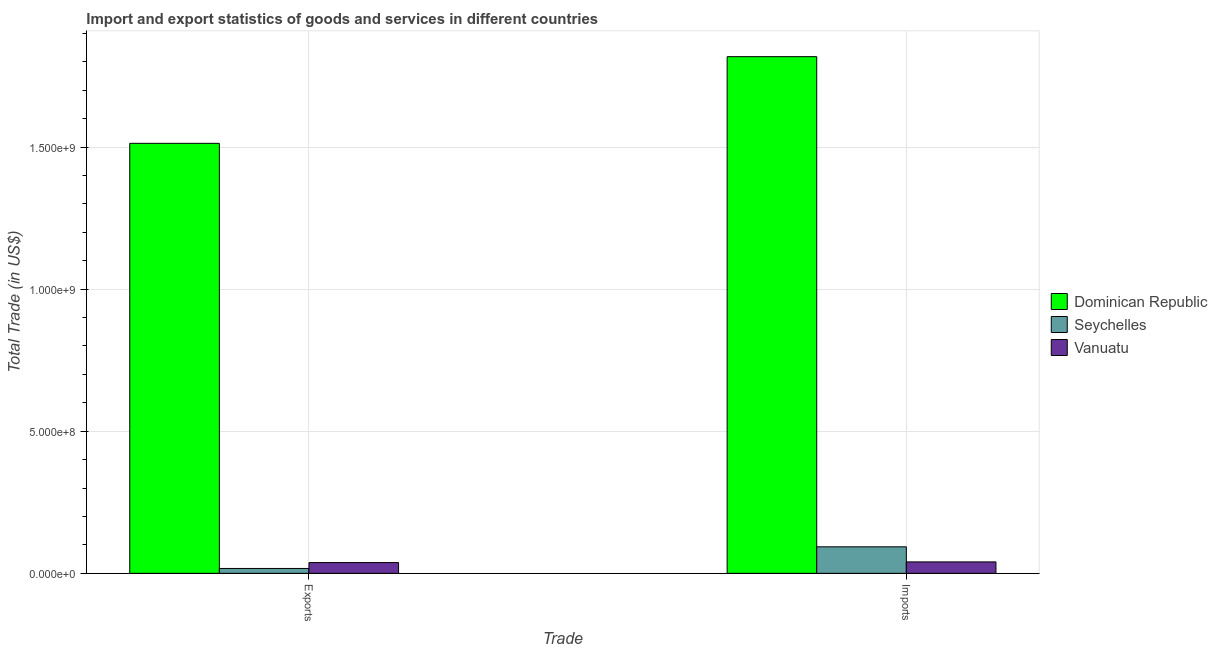How many groups of bars are there?
Keep it short and to the point. 2. Are the number of bars per tick equal to the number of legend labels?
Offer a very short reply. Yes. What is the label of the 2nd group of bars from the left?
Your answer should be very brief. Imports. What is the imports of goods and services in Seychelles?
Provide a short and direct response. 9.33e+07. Across all countries, what is the maximum export of goods and services?
Keep it short and to the point. 1.51e+09. Across all countries, what is the minimum export of goods and services?
Your answer should be very brief. 1.72e+07. In which country was the export of goods and services maximum?
Make the answer very short. Dominican Republic. In which country was the imports of goods and services minimum?
Give a very brief answer. Vanuatu. What is the total export of goods and services in the graph?
Make the answer very short. 1.57e+09. What is the difference between the imports of goods and services in Seychelles and that in Dominican Republic?
Give a very brief answer. -1.72e+09. What is the difference between the imports of goods and services in Seychelles and the export of goods and services in Dominican Republic?
Give a very brief answer. -1.42e+09. What is the average imports of goods and services per country?
Provide a succinct answer. 6.51e+08. What is the difference between the imports of goods and services and export of goods and services in Vanuatu?
Offer a very short reply. 2.33e+06. What is the ratio of the imports of goods and services in Seychelles to that in Vanuatu?
Keep it short and to the point. 2.32. Is the imports of goods and services in Dominican Republic less than that in Vanuatu?
Keep it short and to the point. No. In how many countries, is the imports of goods and services greater than the average imports of goods and services taken over all countries?
Your answer should be compact. 1. What does the 1st bar from the left in Imports represents?
Your response must be concise. Dominican Republic. What does the 2nd bar from the right in Imports represents?
Your answer should be very brief. Seychelles. How many bars are there?
Give a very brief answer. 6. Does the graph contain any zero values?
Keep it short and to the point. No. How many legend labels are there?
Your answer should be very brief. 3. How are the legend labels stacked?
Make the answer very short. Vertical. What is the title of the graph?
Keep it short and to the point. Import and export statistics of goods and services in different countries. What is the label or title of the X-axis?
Offer a very short reply. Trade. What is the label or title of the Y-axis?
Ensure brevity in your answer.  Total Trade (in US$). What is the Total Trade (in US$) of Dominican Republic in Exports?
Offer a terse response. 1.51e+09. What is the Total Trade (in US$) of Seychelles in Exports?
Your answer should be compact. 1.72e+07. What is the Total Trade (in US$) of Vanuatu in Exports?
Provide a succinct answer. 3.79e+07. What is the Total Trade (in US$) of Dominican Republic in Imports?
Keep it short and to the point. 1.82e+09. What is the Total Trade (in US$) of Seychelles in Imports?
Provide a short and direct response. 9.33e+07. What is the Total Trade (in US$) in Vanuatu in Imports?
Your answer should be compact. 4.02e+07. Across all Trade, what is the maximum Total Trade (in US$) in Dominican Republic?
Your answer should be very brief. 1.82e+09. Across all Trade, what is the maximum Total Trade (in US$) in Seychelles?
Make the answer very short. 9.33e+07. Across all Trade, what is the maximum Total Trade (in US$) of Vanuatu?
Your response must be concise. 4.02e+07. Across all Trade, what is the minimum Total Trade (in US$) of Dominican Republic?
Offer a terse response. 1.51e+09. Across all Trade, what is the minimum Total Trade (in US$) of Seychelles?
Keep it short and to the point. 1.72e+07. Across all Trade, what is the minimum Total Trade (in US$) in Vanuatu?
Ensure brevity in your answer.  3.79e+07. What is the total Total Trade (in US$) of Dominican Republic in the graph?
Ensure brevity in your answer.  3.33e+09. What is the total Total Trade (in US$) of Seychelles in the graph?
Give a very brief answer. 1.10e+08. What is the total Total Trade (in US$) of Vanuatu in the graph?
Offer a very short reply. 7.81e+07. What is the difference between the Total Trade (in US$) in Dominican Republic in Exports and that in Imports?
Your answer should be very brief. -3.05e+08. What is the difference between the Total Trade (in US$) of Seychelles in Exports and that in Imports?
Your answer should be compact. -7.61e+07. What is the difference between the Total Trade (in US$) of Vanuatu in Exports and that in Imports?
Your response must be concise. -2.33e+06. What is the difference between the Total Trade (in US$) in Dominican Republic in Exports and the Total Trade (in US$) in Seychelles in Imports?
Provide a short and direct response. 1.42e+09. What is the difference between the Total Trade (in US$) in Dominican Republic in Exports and the Total Trade (in US$) in Vanuatu in Imports?
Provide a succinct answer. 1.47e+09. What is the difference between the Total Trade (in US$) in Seychelles in Exports and the Total Trade (in US$) in Vanuatu in Imports?
Offer a terse response. -2.31e+07. What is the average Total Trade (in US$) of Dominican Republic per Trade?
Keep it short and to the point. 1.67e+09. What is the average Total Trade (in US$) of Seychelles per Trade?
Offer a very short reply. 5.52e+07. What is the average Total Trade (in US$) in Vanuatu per Trade?
Give a very brief answer. 3.91e+07. What is the difference between the Total Trade (in US$) of Dominican Republic and Total Trade (in US$) of Seychelles in Exports?
Make the answer very short. 1.50e+09. What is the difference between the Total Trade (in US$) of Dominican Republic and Total Trade (in US$) of Vanuatu in Exports?
Make the answer very short. 1.48e+09. What is the difference between the Total Trade (in US$) in Seychelles and Total Trade (in US$) in Vanuatu in Exports?
Your answer should be compact. -2.07e+07. What is the difference between the Total Trade (in US$) of Dominican Republic and Total Trade (in US$) of Seychelles in Imports?
Ensure brevity in your answer.  1.72e+09. What is the difference between the Total Trade (in US$) in Dominican Republic and Total Trade (in US$) in Vanuatu in Imports?
Ensure brevity in your answer.  1.78e+09. What is the difference between the Total Trade (in US$) of Seychelles and Total Trade (in US$) of Vanuatu in Imports?
Ensure brevity in your answer.  5.30e+07. What is the ratio of the Total Trade (in US$) in Dominican Republic in Exports to that in Imports?
Your answer should be very brief. 0.83. What is the ratio of the Total Trade (in US$) in Seychelles in Exports to that in Imports?
Your response must be concise. 0.18. What is the ratio of the Total Trade (in US$) of Vanuatu in Exports to that in Imports?
Make the answer very short. 0.94. What is the difference between the highest and the second highest Total Trade (in US$) in Dominican Republic?
Ensure brevity in your answer.  3.05e+08. What is the difference between the highest and the second highest Total Trade (in US$) of Seychelles?
Ensure brevity in your answer.  7.61e+07. What is the difference between the highest and the second highest Total Trade (in US$) of Vanuatu?
Provide a short and direct response. 2.33e+06. What is the difference between the highest and the lowest Total Trade (in US$) of Dominican Republic?
Make the answer very short. 3.05e+08. What is the difference between the highest and the lowest Total Trade (in US$) of Seychelles?
Your answer should be very brief. 7.61e+07. What is the difference between the highest and the lowest Total Trade (in US$) in Vanuatu?
Provide a short and direct response. 2.33e+06. 